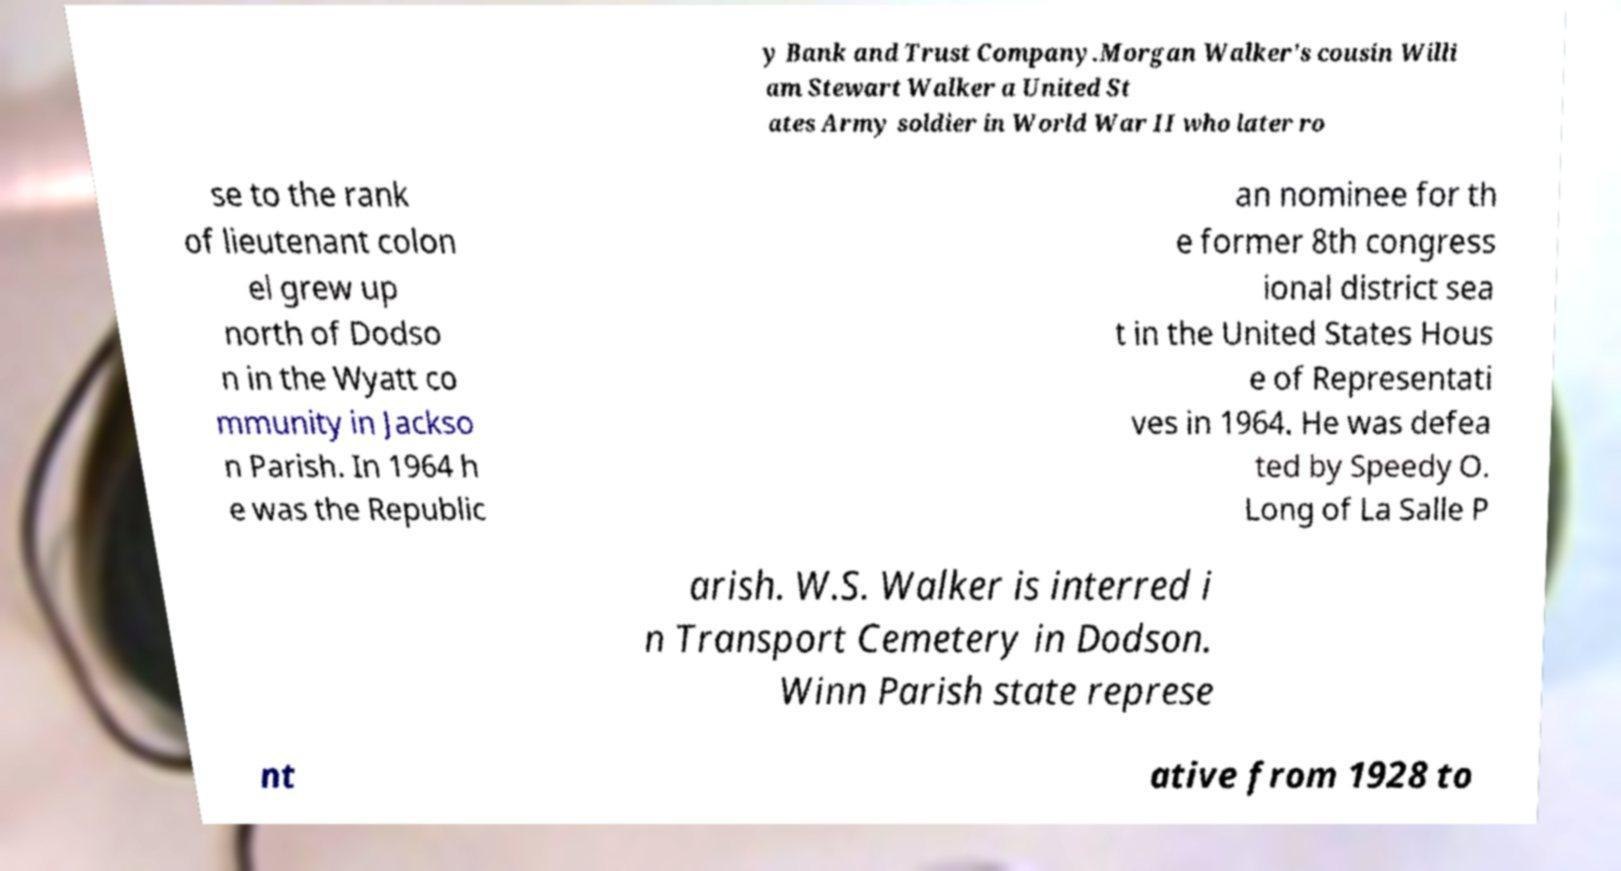Can you accurately transcribe the text from the provided image for me? y Bank and Trust Company.Morgan Walker's cousin Willi am Stewart Walker a United St ates Army soldier in World War II who later ro se to the rank of lieutenant colon el grew up north of Dodso n in the Wyatt co mmunity in Jackso n Parish. In 1964 h e was the Republic an nominee for th e former 8th congress ional district sea t in the United States Hous e of Representati ves in 1964. He was defea ted by Speedy O. Long of La Salle P arish. W.S. Walker is interred i n Transport Cemetery in Dodson. Winn Parish state represe nt ative from 1928 to 